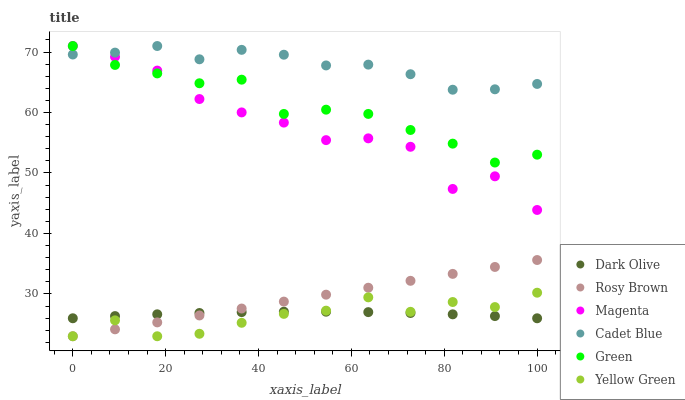Does Yellow Green have the minimum area under the curve?
Answer yes or no. Yes. Does Cadet Blue have the maximum area under the curve?
Answer yes or no. Yes. Does Dark Olive have the minimum area under the curve?
Answer yes or no. No. Does Dark Olive have the maximum area under the curve?
Answer yes or no. No. Is Rosy Brown the smoothest?
Answer yes or no. Yes. Is Magenta the roughest?
Answer yes or no. Yes. Is Yellow Green the smoothest?
Answer yes or no. No. Is Yellow Green the roughest?
Answer yes or no. No. Does Yellow Green have the lowest value?
Answer yes or no. Yes. Does Dark Olive have the lowest value?
Answer yes or no. No. Does Magenta have the highest value?
Answer yes or no. Yes. Does Yellow Green have the highest value?
Answer yes or no. No. Is Yellow Green less than Magenta?
Answer yes or no. Yes. Is Magenta greater than Dark Olive?
Answer yes or no. Yes. Does Green intersect Cadet Blue?
Answer yes or no. Yes. Is Green less than Cadet Blue?
Answer yes or no. No. Is Green greater than Cadet Blue?
Answer yes or no. No. Does Yellow Green intersect Magenta?
Answer yes or no. No. 